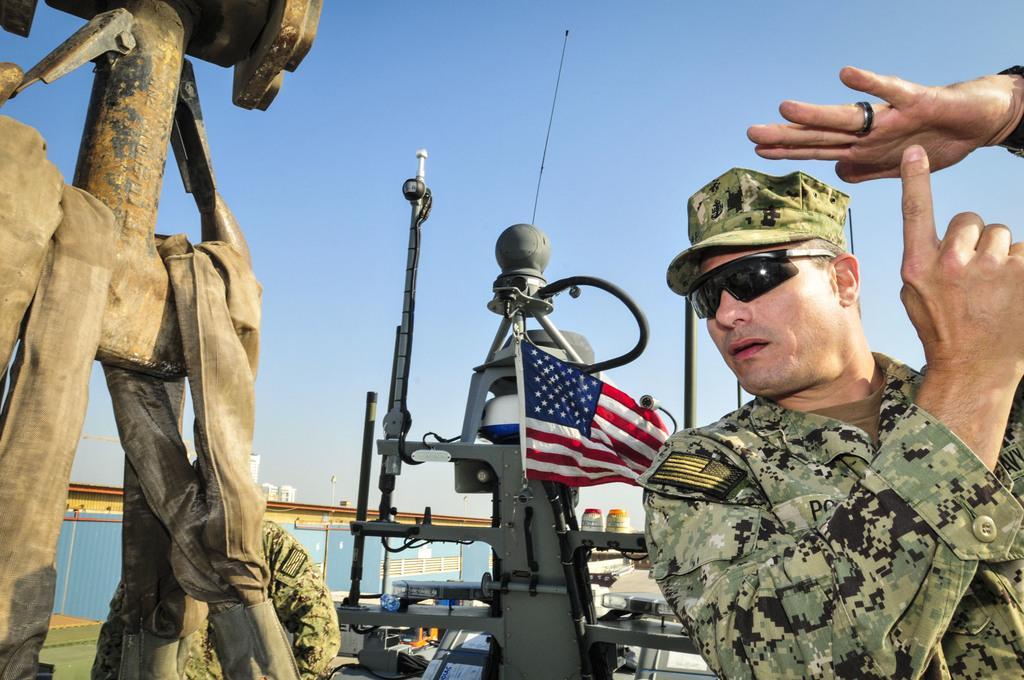In one or two sentences, can you explain what this image depicts? In this image we can see two persons, there are mechanical instruments, there is a wall, a flag, there are houses, also we can see the sky. 